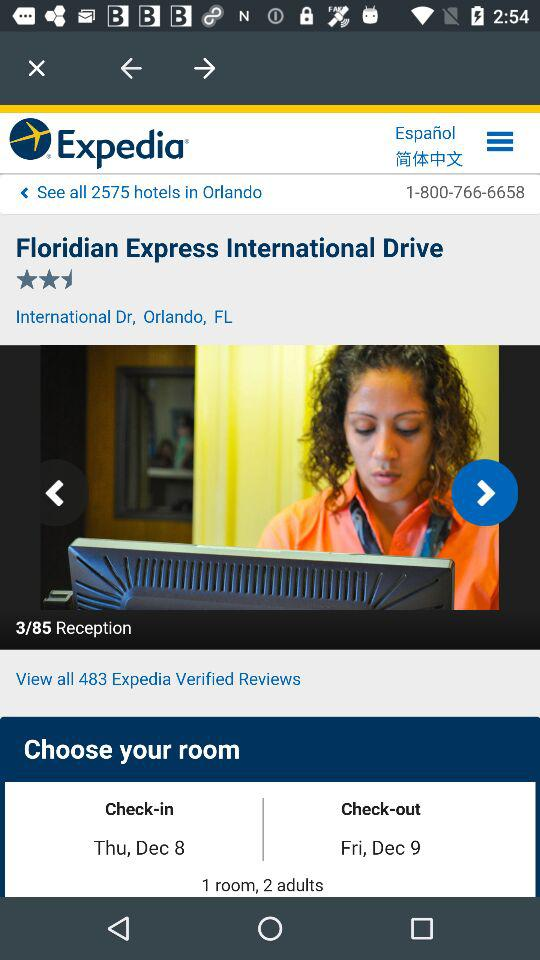What's the number of rooms to be booked? The number of rooms to be booked is 1. 